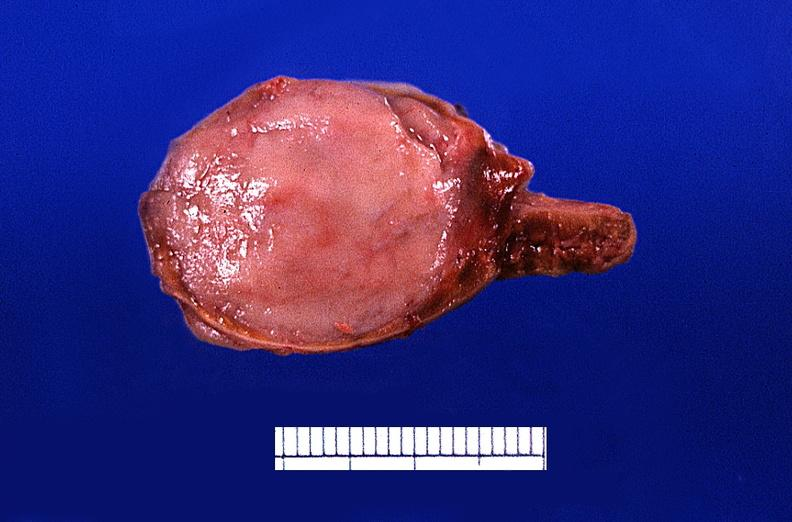s endocrine present?
Answer the question using a single word or phrase. Yes 